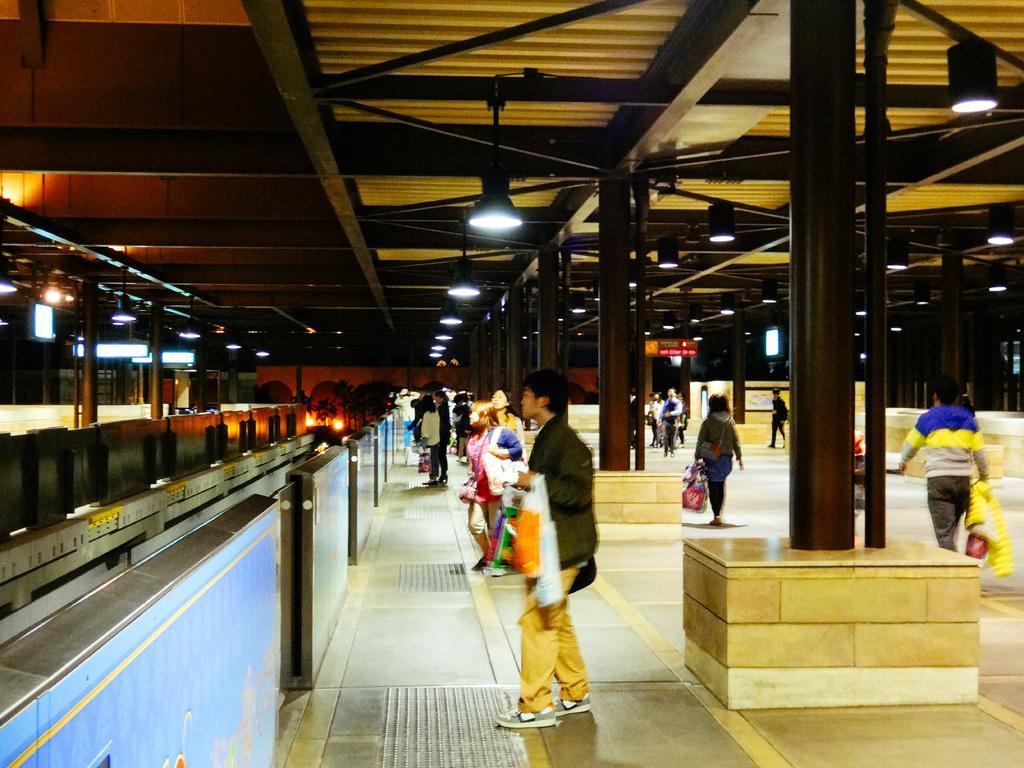Please provide a concise description of this image. In this image in the middle there is a man, he wears a jacket, trouser, shoes. On the left there are lights, pillars, roof. On the right there is a man, he wears a t shirt, trouser, he is walking. In the background there are many people, lights, pillars, floor. 